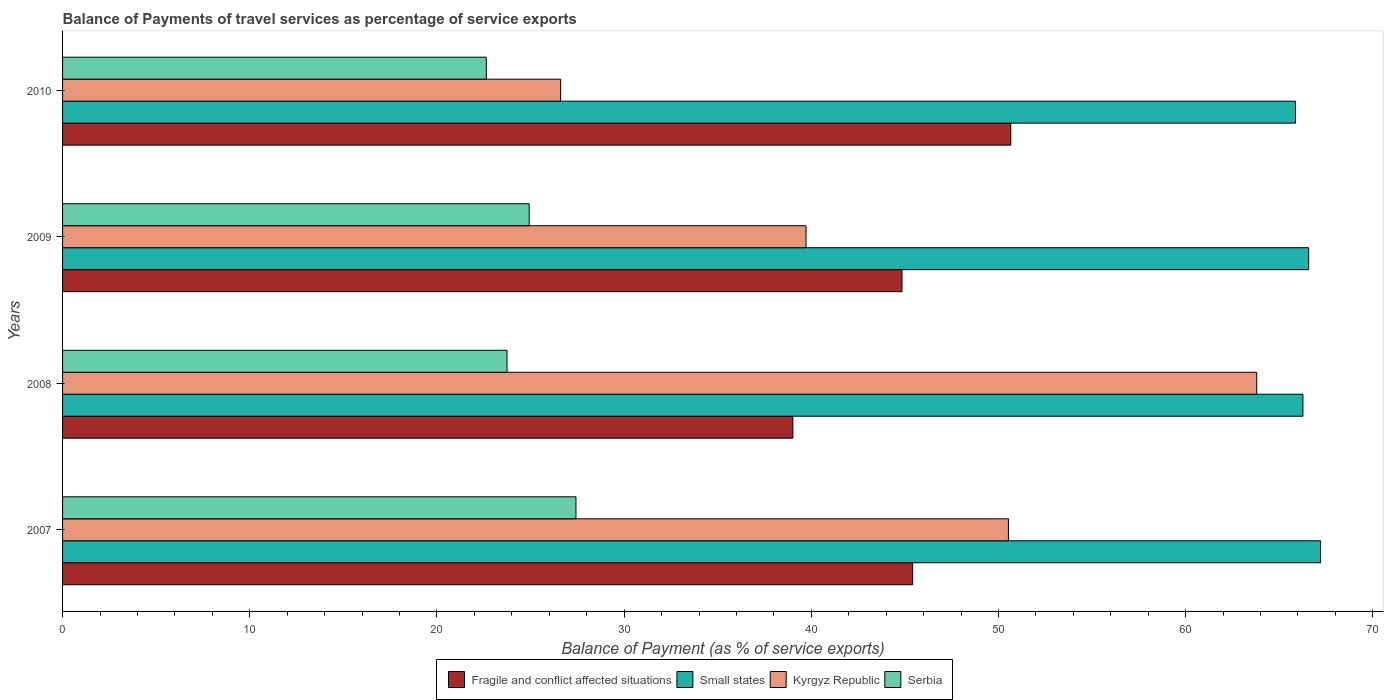How many groups of bars are there?
Offer a terse response. 4. Are the number of bars per tick equal to the number of legend labels?
Keep it short and to the point. Yes. How many bars are there on the 1st tick from the bottom?
Your response must be concise. 4. What is the label of the 2nd group of bars from the top?
Offer a very short reply. 2009. What is the balance of payments of travel services in Kyrgyz Republic in 2008?
Your answer should be very brief. 63.79. Across all years, what is the maximum balance of payments of travel services in Kyrgyz Republic?
Keep it short and to the point. 63.79. Across all years, what is the minimum balance of payments of travel services in Serbia?
Your response must be concise. 22.64. In which year was the balance of payments of travel services in Kyrgyz Republic maximum?
Provide a succinct answer. 2008. What is the total balance of payments of travel services in Kyrgyz Republic in the graph?
Provide a succinct answer. 180.65. What is the difference between the balance of payments of travel services in Small states in 2008 and that in 2009?
Provide a succinct answer. -0.31. What is the difference between the balance of payments of travel services in Kyrgyz Republic in 2010 and the balance of payments of travel services in Small states in 2007?
Provide a short and direct response. -40.6. What is the average balance of payments of travel services in Small states per year?
Give a very brief answer. 66.48. In the year 2008, what is the difference between the balance of payments of travel services in Serbia and balance of payments of travel services in Kyrgyz Republic?
Provide a succinct answer. -40.05. In how many years, is the balance of payments of travel services in Kyrgyz Republic greater than 50 %?
Make the answer very short. 2. What is the ratio of the balance of payments of travel services in Serbia in 2007 to that in 2010?
Make the answer very short. 1.21. Is the difference between the balance of payments of travel services in Serbia in 2008 and 2009 greater than the difference between the balance of payments of travel services in Kyrgyz Republic in 2008 and 2009?
Provide a succinct answer. No. What is the difference between the highest and the second highest balance of payments of travel services in Small states?
Keep it short and to the point. 0.64. What is the difference between the highest and the lowest balance of payments of travel services in Kyrgyz Republic?
Provide a succinct answer. 37.19. Is the sum of the balance of payments of travel services in Fragile and conflict affected situations in 2007 and 2010 greater than the maximum balance of payments of travel services in Kyrgyz Republic across all years?
Give a very brief answer. Yes. Is it the case that in every year, the sum of the balance of payments of travel services in Small states and balance of payments of travel services in Kyrgyz Republic is greater than the sum of balance of payments of travel services in Serbia and balance of payments of travel services in Fragile and conflict affected situations?
Offer a very short reply. No. What does the 2nd bar from the top in 2010 represents?
Your answer should be very brief. Kyrgyz Republic. What does the 3rd bar from the bottom in 2009 represents?
Give a very brief answer. Kyrgyz Republic. How many bars are there?
Offer a terse response. 16. Are all the bars in the graph horizontal?
Your answer should be very brief. Yes. What is the difference between two consecutive major ticks on the X-axis?
Keep it short and to the point. 10. Are the values on the major ticks of X-axis written in scientific E-notation?
Your response must be concise. No. Does the graph contain any zero values?
Provide a short and direct response. No. How many legend labels are there?
Make the answer very short. 4. What is the title of the graph?
Your answer should be very brief. Balance of Payments of travel services as percentage of service exports. Does "East Asia (all income levels)" appear as one of the legend labels in the graph?
Give a very brief answer. No. What is the label or title of the X-axis?
Your response must be concise. Balance of Payment (as % of service exports). What is the Balance of Payment (as % of service exports) of Fragile and conflict affected situations in 2007?
Offer a terse response. 45.41. What is the Balance of Payment (as % of service exports) in Small states in 2007?
Give a very brief answer. 67.21. What is the Balance of Payment (as % of service exports) of Kyrgyz Republic in 2007?
Your answer should be compact. 50.53. What is the Balance of Payment (as % of service exports) of Serbia in 2007?
Your response must be concise. 27.43. What is the Balance of Payment (as % of service exports) in Fragile and conflict affected situations in 2008?
Ensure brevity in your answer.  39.02. What is the Balance of Payment (as % of service exports) in Small states in 2008?
Your answer should be compact. 66.26. What is the Balance of Payment (as % of service exports) of Kyrgyz Republic in 2008?
Your answer should be compact. 63.79. What is the Balance of Payment (as % of service exports) in Serbia in 2008?
Your response must be concise. 23.74. What is the Balance of Payment (as % of service exports) in Fragile and conflict affected situations in 2009?
Your response must be concise. 44.84. What is the Balance of Payment (as % of service exports) of Small states in 2009?
Ensure brevity in your answer.  66.57. What is the Balance of Payment (as % of service exports) of Kyrgyz Republic in 2009?
Offer a terse response. 39.72. What is the Balance of Payment (as % of service exports) of Serbia in 2009?
Ensure brevity in your answer.  24.93. What is the Balance of Payment (as % of service exports) of Fragile and conflict affected situations in 2010?
Give a very brief answer. 50.66. What is the Balance of Payment (as % of service exports) in Small states in 2010?
Offer a terse response. 65.87. What is the Balance of Payment (as % of service exports) in Kyrgyz Republic in 2010?
Make the answer very short. 26.61. What is the Balance of Payment (as % of service exports) in Serbia in 2010?
Make the answer very short. 22.64. Across all years, what is the maximum Balance of Payment (as % of service exports) of Fragile and conflict affected situations?
Ensure brevity in your answer.  50.66. Across all years, what is the maximum Balance of Payment (as % of service exports) of Small states?
Your answer should be very brief. 67.21. Across all years, what is the maximum Balance of Payment (as % of service exports) of Kyrgyz Republic?
Your answer should be compact. 63.79. Across all years, what is the maximum Balance of Payment (as % of service exports) in Serbia?
Offer a terse response. 27.43. Across all years, what is the minimum Balance of Payment (as % of service exports) in Fragile and conflict affected situations?
Your response must be concise. 39.02. Across all years, what is the minimum Balance of Payment (as % of service exports) of Small states?
Provide a succinct answer. 65.87. Across all years, what is the minimum Balance of Payment (as % of service exports) in Kyrgyz Republic?
Provide a short and direct response. 26.61. Across all years, what is the minimum Balance of Payment (as % of service exports) of Serbia?
Ensure brevity in your answer.  22.64. What is the total Balance of Payment (as % of service exports) of Fragile and conflict affected situations in the graph?
Ensure brevity in your answer.  179.93. What is the total Balance of Payment (as % of service exports) of Small states in the graph?
Ensure brevity in your answer.  265.91. What is the total Balance of Payment (as % of service exports) of Kyrgyz Republic in the graph?
Offer a very short reply. 180.65. What is the total Balance of Payment (as % of service exports) of Serbia in the graph?
Provide a short and direct response. 98.74. What is the difference between the Balance of Payment (as % of service exports) of Fragile and conflict affected situations in 2007 and that in 2008?
Offer a very short reply. 6.4. What is the difference between the Balance of Payment (as % of service exports) in Small states in 2007 and that in 2008?
Your answer should be compact. 0.94. What is the difference between the Balance of Payment (as % of service exports) in Kyrgyz Republic in 2007 and that in 2008?
Your response must be concise. -13.26. What is the difference between the Balance of Payment (as % of service exports) in Serbia in 2007 and that in 2008?
Ensure brevity in your answer.  3.68. What is the difference between the Balance of Payment (as % of service exports) in Fragile and conflict affected situations in 2007 and that in 2009?
Your answer should be very brief. 0.57. What is the difference between the Balance of Payment (as % of service exports) of Small states in 2007 and that in 2009?
Your response must be concise. 0.64. What is the difference between the Balance of Payment (as % of service exports) in Kyrgyz Republic in 2007 and that in 2009?
Make the answer very short. 10.81. What is the difference between the Balance of Payment (as % of service exports) of Serbia in 2007 and that in 2009?
Your answer should be very brief. 2.5. What is the difference between the Balance of Payment (as % of service exports) of Fragile and conflict affected situations in 2007 and that in 2010?
Offer a very short reply. -5.24. What is the difference between the Balance of Payment (as % of service exports) of Small states in 2007 and that in 2010?
Your answer should be very brief. 1.34. What is the difference between the Balance of Payment (as % of service exports) in Kyrgyz Republic in 2007 and that in 2010?
Your answer should be compact. 23.92. What is the difference between the Balance of Payment (as % of service exports) in Serbia in 2007 and that in 2010?
Your answer should be compact. 4.79. What is the difference between the Balance of Payment (as % of service exports) of Fragile and conflict affected situations in 2008 and that in 2009?
Your answer should be compact. -5.83. What is the difference between the Balance of Payment (as % of service exports) in Small states in 2008 and that in 2009?
Offer a terse response. -0.31. What is the difference between the Balance of Payment (as % of service exports) in Kyrgyz Republic in 2008 and that in 2009?
Your answer should be very brief. 24.08. What is the difference between the Balance of Payment (as % of service exports) in Serbia in 2008 and that in 2009?
Offer a terse response. -1.18. What is the difference between the Balance of Payment (as % of service exports) of Fragile and conflict affected situations in 2008 and that in 2010?
Offer a terse response. -11.64. What is the difference between the Balance of Payment (as % of service exports) of Small states in 2008 and that in 2010?
Make the answer very short. 0.4. What is the difference between the Balance of Payment (as % of service exports) of Kyrgyz Republic in 2008 and that in 2010?
Keep it short and to the point. 37.19. What is the difference between the Balance of Payment (as % of service exports) in Serbia in 2008 and that in 2010?
Ensure brevity in your answer.  1.1. What is the difference between the Balance of Payment (as % of service exports) of Fragile and conflict affected situations in 2009 and that in 2010?
Provide a succinct answer. -5.81. What is the difference between the Balance of Payment (as % of service exports) in Small states in 2009 and that in 2010?
Provide a succinct answer. 0.71. What is the difference between the Balance of Payment (as % of service exports) of Kyrgyz Republic in 2009 and that in 2010?
Keep it short and to the point. 13.11. What is the difference between the Balance of Payment (as % of service exports) in Serbia in 2009 and that in 2010?
Provide a succinct answer. 2.29. What is the difference between the Balance of Payment (as % of service exports) in Fragile and conflict affected situations in 2007 and the Balance of Payment (as % of service exports) in Small states in 2008?
Give a very brief answer. -20.85. What is the difference between the Balance of Payment (as % of service exports) of Fragile and conflict affected situations in 2007 and the Balance of Payment (as % of service exports) of Kyrgyz Republic in 2008?
Provide a succinct answer. -18.38. What is the difference between the Balance of Payment (as % of service exports) in Fragile and conflict affected situations in 2007 and the Balance of Payment (as % of service exports) in Serbia in 2008?
Keep it short and to the point. 21.67. What is the difference between the Balance of Payment (as % of service exports) of Small states in 2007 and the Balance of Payment (as % of service exports) of Kyrgyz Republic in 2008?
Ensure brevity in your answer.  3.41. What is the difference between the Balance of Payment (as % of service exports) in Small states in 2007 and the Balance of Payment (as % of service exports) in Serbia in 2008?
Your answer should be very brief. 43.46. What is the difference between the Balance of Payment (as % of service exports) in Kyrgyz Republic in 2007 and the Balance of Payment (as % of service exports) in Serbia in 2008?
Your answer should be compact. 26.79. What is the difference between the Balance of Payment (as % of service exports) of Fragile and conflict affected situations in 2007 and the Balance of Payment (as % of service exports) of Small states in 2009?
Your answer should be compact. -21.16. What is the difference between the Balance of Payment (as % of service exports) of Fragile and conflict affected situations in 2007 and the Balance of Payment (as % of service exports) of Kyrgyz Republic in 2009?
Make the answer very short. 5.7. What is the difference between the Balance of Payment (as % of service exports) in Fragile and conflict affected situations in 2007 and the Balance of Payment (as % of service exports) in Serbia in 2009?
Provide a succinct answer. 20.49. What is the difference between the Balance of Payment (as % of service exports) of Small states in 2007 and the Balance of Payment (as % of service exports) of Kyrgyz Republic in 2009?
Make the answer very short. 27.49. What is the difference between the Balance of Payment (as % of service exports) of Small states in 2007 and the Balance of Payment (as % of service exports) of Serbia in 2009?
Your answer should be compact. 42.28. What is the difference between the Balance of Payment (as % of service exports) in Kyrgyz Republic in 2007 and the Balance of Payment (as % of service exports) in Serbia in 2009?
Offer a very short reply. 25.6. What is the difference between the Balance of Payment (as % of service exports) of Fragile and conflict affected situations in 2007 and the Balance of Payment (as % of service exports) of Small states in 2010?
Provide a short and direct response. -20.45. What is the difference between the Balance of Payment (as % of service exports) of Fragile and conflict affected situations in 2007 and the Balance of Payment (as % of service exports) of Kyrgyz Republic in 2010?
Keep it short and to the point. 18.81. What is the difference between the Balance of Payment (as % of service exports) in Fragile and conflict affected situations in 2007 and the Balance of Payment (as % of service exports) in Serbia in 2010?
Provide a short and direct response. 22.77. What is the difference between the Balance of Payment (as % of service exports) in Small states in 2007 and the Balance of Payment (as % of service exports) in Kyrgyz Republic in 2010?
Your response must be concise. 40.6. What is the difference between the Balance of Payment (as % of service exports) of Small states in 2007 and the Balance of Payment (as % of service exports) of Serbia in 2010?
Provide a short and direct response. 44.57. What is the difference between the Balance of Payment (as % of service exports) in Kyrgyz Republic in 2007 and the Balance of Payment (as % of service exports) in Serbia in 2010?
Your answer should be compact. 27.89. What is the difference between the Balance of Payment (as % of service exports) of Fragile and conflict affected situations in 2008 and the Balance of Payment (as % of service exports) of Small states in 2009?
Make the answer very short. -27.56. What is the difference between the Balance of Payment (as % of service exports) in Fragile and conflict affected situations in 2008 and the Balance of Payment (as % of service exports) in Kyrgyz Republic in 2009?
Offer a very short reply. -0.7. What is the difference between the Balance of Payment (as % of service exports) in Fragile and conflict affected situations in 2008 and the Balance of Payment (as % of service exports) in Serbia in 2009?
Your answer should be very brief. 14.09. What is the difference between the Balance of Payment (as % of service exports) of Small states in 2008 and the Balance of Payment (as % of service exports) of Kyrgyz Republic in 2009?
Provide a short and direct response. 26.55. What is the difference between the Balance of Payment (as % of service exports) of Small states in 2008 and the Balance of Payment (as % of service exports) of Serbia in 2009?
Keep it short and to the point. 41.34. What is the difference between the Balance of Payment (as % of service exports) in Kyrgyz Republic in 2008 and the Balance of Payment (as % of service exports) in Serbia in 2009?
Make the answer very short. 38.87. What is the difference between the Balance of Payment (as % of service exports) of Fragile and conflict affected situations in 2008 and the Balance of Payment (as % of service exports) of Small states in 2010?
Keep it short and to the point. -26.85. What is the difference between the Balance of Payment (as % of service exports) of Fragile and conflict affected situations in 2008 and the Balance of Payment (as % of service exports) of Kyrgyz Republic in 2010?
Ensure brevity in your answer.  12.41. What is the difference between the Balance of Payment (as % of service exports) in Fragile and conflict affected situations in 2008 and the Balance of Payment (as % of service exports) in Serbia in 2010?
Offer a very short reply. 16.38. What is the difference between the Balance of Payment (as % of service exports) of Small states in 2008 and the Balance of Payment (as % of service exports) of Kyrgyz Republic in 2010?
Keep it short and to the point. 39.66. What is the difference between the Balance of Payment (as % of service exports) in Small states in 2008 and the Balance of Payment (as % of service exports) in Serbia in 2010?
Provide a succinct answer. 43.62. What is the difference between the Balance of Payment (as % of service exports) of Kyrgyz Republic in 2008 and the Balance of Payment (as % of service exports) of Serbia in 2010?
Provide a short and direct response. 41.15. What is the difference between the Balance of Payment (as % of service exports) in Fragile and conflict affected situations in 2009 and the Balance of Payment (as % of service exports) in Small states in 2010?
Provide a short and direct response. -21.02. What is the difference between the Balance of Payment (as % of service exports) in Fragile and conflict affected situations in 2009 and the Balance of Payment (as % of service exports) in Kyrgyz Republic in 2010?
Your answer should be very brief. 18.24. What is the difference between the Balance of Payment (as % of service exports) in Fragile and conflict affected situations in 2009 and the Balance of Payment (as % of service exports) in Serbia in 2010?
Ensure brevity in your answer.  22.2. What is the difference between the Balance of Payment (as % of service exports) in Small states in 2009 and the Balance of Payment (as % of service exports) in Kyrgyz Republic in 2010?
Your response must be concise. 39.96. What is the difference between the Balance of Payment (as % of service exports) in Small states in 2009 and the Balance of Payment (as % of service exports) in Serbia in 2010?
Keep it short and to the point. 43.93. What is the difference between the Balance of Payment (as % of service exports) in Kyrgyz Republic in 2009 and the Balance of Payment (as % of service exports) in Serbia in 2010?
Give a very brief answer. 17.08. What is the average Balance of Payment (as % of service exports) of Fragile and conflict affected situations per year?
Your response must be concise. 44.98. What is the average Balance of Payment (as % of service exports) of Small states per year?
Your response must be concise. 66.48. What is the average Balance of Payment (as % of service exports) of Kyrgyz Republic per year?
Offer a very short reply. 45.16. What is the average Balance of Payment (as % of service exports) in Serbia per year?
Provide a succinct answer. 24.68. In the year 2007, what is the difference between the Balance of Payment (as % of service exports) in Fragile and conflict affected situations and Balance of Payment (as % of service exports) in Small states?
Keep it short and to the point. -21.79. In the year 2007, what is the difference between the Balance of Payment (as % of service exports) of Fragile and conflict affected situations and Balance of Payment (as % of service exports) of Kyrgyz Republic?
Offer a terse response. -5.12. In the year 2007, what is the difference between the Balance of Payment (as % of service exports) of Fragile and conflict affected situations and Balance of Payment (as % of service exports) of Serbia?
Make the answer very short. 17.99. In the year 2007, what is the difference between the Balance of Payment (as % of service exports) in Small states and Balance of Payment (as % of service exports) in Kyrgyz Republic?
Keep it short and to the point. 16.68. In the year 2007, what is the difference between the Balance of Payment (as % of service exports) of Small states and Balance of Payment (as % of service exports) of Serbia?
Your response must be concise. 39.78. In the year 2007, what is the difference between the Balance of Payment (as % of service exports) of Kyrgyz Republic and Balance of Payment (as % of service exports) of Serbia?
Give a very brief answer. 23.1. In the year 2008, what is the difference between the Balance of Payment (as % of service exports) of Fragile and conflict affected situations and Balance of Payment (as % of service exports) of Small states?
Your response must be concise. -27.25. In the year 2008, what is the difference between the Balance of Payment (as % of service exports) in Fragile and conflict affected situations and Balance of Payment (as % of service exports) in Kyrgyz Republic?
Your answer should be very brief. -24.78. In the year 2008, what is the difference between the Balance of Payment (as % of service exports) in Fragile and conflict affected situations and Balance of Payment (as % of service exports) in Serbia?
Your answer should be compact. 15.27. In the year 2008, what is the difference between the Balance of Payment (as % of service exports) in Small states and Balance of Payment (as % of service exports) in Kyrgyz Republic?
Provide a succinct answer. 2.47. In the year 2008, what is the difference between the Balance of Payment (as % of service exports) of Small states and Balance of Payment (as % of service exports) of Serbia?
Give a very brief answer. 42.52. In the year 2008, what is the difference between the Balance of Payment (as % of service exports) of Kyrgyz Republic and Balance of Payment (as % of service exports) of Serbia?
Your answer should be very brief. 40.05. In the year 2009, what is the difference between the Balance of Payment (as % of service exports) in Fragile and conflict affected situations and Balance of Payment (as % of service exports) in Small states?
Provide a succinct answer. -21.73. In the year 2009, what is the difference between the Balance of Payment (as % of service exports) of Fragile and conflict affected situations and Balance of Payment (as % of service exports) of Kyrgyz Republic?
Ensure brevity in your answer.  5.13. In the year 2009, what is the difference between the Balance of Payment (as % of service exports) in Fragile and conflict affected situations and Balance of Payment (as % of service exports) in Serbia?
Provide a succinct answer. 19.92. In the year 2009, what is the difference between the Balance of Payment (as % of service exports) in Small states and Balance of Payment (as % of service exports) in Kyrgyz Republic?
Give a very brief answer. 26.85. In the year 2009, what is the difference between the Balance of Payment (as % of service exports) of Small states and Balance of Payment (as % of service exports) of Serbia?
Keep it short and to the point. 41.64. In the year 2009, what is the difference between the Balance of Payment (as % of service exports) in Kyrgyz Republic and Balance of Payment (as % of service exports) in Serbia?
Your answer should be very brief. 14.79. In the year 2010, what is the difference between the Balance of Payment (as % of service exports) in Fragile and conflict affected situations and Balance of Payment (as % of service exports) in Small states?
Your answer should be very brief. -15.21. In the year 2010, what is the difference between the Balance of Payment (as % of service exports) of Fragile and conflict affected situations and Balance of Payment (as % of service exports) of Kyrgyz Republic?
Give a very brief answer. 24.05. In the year 2010, what is the difference between the Balance of Payment (as % of service exports) in Fragile and conflict affected situations and Balance of Payment (as % of service exports) in Serbia?
Provide a short and direct response. 28.02. In the year 2010, what is the difference between the Balance of Payment (as % of service exports) of Small states and Balance of Payment (as % of service exports) of Kyrgyz Republic?
Offer a terse response. 39.26. In the year 2010, what is the difference between the Balance of Payment (as % of service exports) in Small states and Balance of Payment (as % of service exports) in Serbia?
Ensure brevity in your answer.  43.23. In the year 2010, what is the difference between the Balance of Payment (as % of service exports) of Kyrgyz Republic and Balance of Payment (as % of service exports) of Serbia?
Your response must be concise. 3.97. What is the ratio of the Balance of Payment (as % of service exports) of Fragile and conflict affected situations in 2007 to that in 2008?
Make the answer very short. 1.16. What is the ratio of the Balance of Payment (as % of service exports) in Small states in 2007 to that in 2008?
Your answer should be compact. 1.01. What is the ratio of the Balance of Payment (as % of service exports) of Kyrgyz Republic in 2007 to that in 2008?
Keep it short and to the point. 0.79. What is the ratio of the Balance of Payment (as % of service exports) of Serbia in 2007 to that in 2008?
Your response must be concise. 1.16. What is the ratio of the Balance of Payment (as % of service exports) in Fragile and conflict affected situations in 2007 to that in 2009?
Give a very brief answer. 1.01. What is the ratio of the Balance of Payment (as % of service exports) in Small states in 2007 to that in 2009?
Ensure brevity in your answer.  1.01. What is the ratio of the Balance of Payment (as % of service exports) in Kyrgyz Republic in 2007 to that in 2009?
Provide a succinct answer. 1.27. What is the ratio of the Balance of Payment (as % of service exports) in Serbia in 2007 to that in 2009?
Ensure brevity in your answer.  1.1. What is the ratio of the Balance of Payment (as % of service exports) in Fragile and conflict affected situations in 2007 to that in 2010?
Provide a short and direct response. 0.9. What is the ratio of the Balance of Payment (as % of service exports) in Small states in 2007 to that in 2010?
Make the answer very short. 1.02. What is the ratio of the Balance of Payment (as % of service exports) in Kyrgyz Republic in 2007 to that in 2010?
Your response must be concise. 1.9. What is the ratio of the Balance of Payment (as % of service exports) in Serbia in 2007 to that in 2010?
Your answer should be very brief. 1.21. What is the ratio of the Balance of Payment (as % of service exports) in Fragile and conflict affected situations in 2008 to that in 2009?
Offer a very short reply. 0.87. What is the ratio of the Balance of Payment (as % of service exports) in Small states in 2008 to that in 2009?
Keep it short and to the point. 1. What is the ratio of the Balance of Payment (as % of service exports) of Kyrgyz Republic in 2008 to that in 2009?
Your answer should be very brief. 1.61. What is the ratio of the Balance of Payment (as % of service exports) in Serbia in 2008 to that in 2009?
Provide a succinct answer. 0.95. What is the ratio of the Balance of Payment (as % of service exports) in Fragile and conflict affected situations in 2008 to that in 2010?
Keep it short and to the point. 0.77. What is the ratio of the Balance of Payment (as % of service exports) of Kyrgyz Republic in 2008 to that in 2010?
Give a very brief answer. 2.4. What is the ratio of the Balance of Payment (as % of service exports) in Serbia in 2008 to that in 2010?
Offer a terse response. 1.05. What is the ratio of the Balance of Payment (as % of service exports) in Fragile and conflict affected situations in 2009 to that in 2010?
Provide a succinct answer. 0.89. What is the ratio of the Balance of Payment (as % of service exports) of Small states in 2009 to that in 2010?
Keep it short and to the point. 1.01. What is the ratio of the Balance of Payment (as % of service exports) in Kyrgyz Republic in 2009 to that in 2010?
Offer a terse response. 1.49. What is the ratio of the Balance of Payment (as % of service exports) of Serbia in 2009 to that in 2010?
Provide a succinct answer. 1.1. What is the difference between the highest and the second highest Balance of Payment (as % of service exports) of Fragile and conflict affected situations?
Ensure brevity in your answer.  5.24. What is the difference between the highest and the second highest Balance of Payment (as % of service exports) of Small states?
Your answer should be compact. 0.64. What is the difference between the highest and the second highest Balance of Payment (as % of service exports) in Kyrgyz Republic?
Make the answer very short. 13.26. What is the difference between the highest and the second highest Balance of Payment (as % of service exports) of Serbia?
Your answer should be compact. 2.5. What is the difference between the highest and the lowest Balance of Payment (as % of service exports) in Fragile and conflict affected situations?
Provide a short and direct response. 11.64. What is the difference between the highest and the lowest Balance of Payment (as % of service exports) of Small states?
Offer a very short reply. 1.34. What is the difference between the highest and the lowest Balance of Payment (as % of service exports) in Kyrgyz Republic?
Offer a very short reply. 37.19. What is the difference between the highest and the lowest Balance of Payment (as % of service exports) in Serbia?
Your answer should be compact. 4.79. 